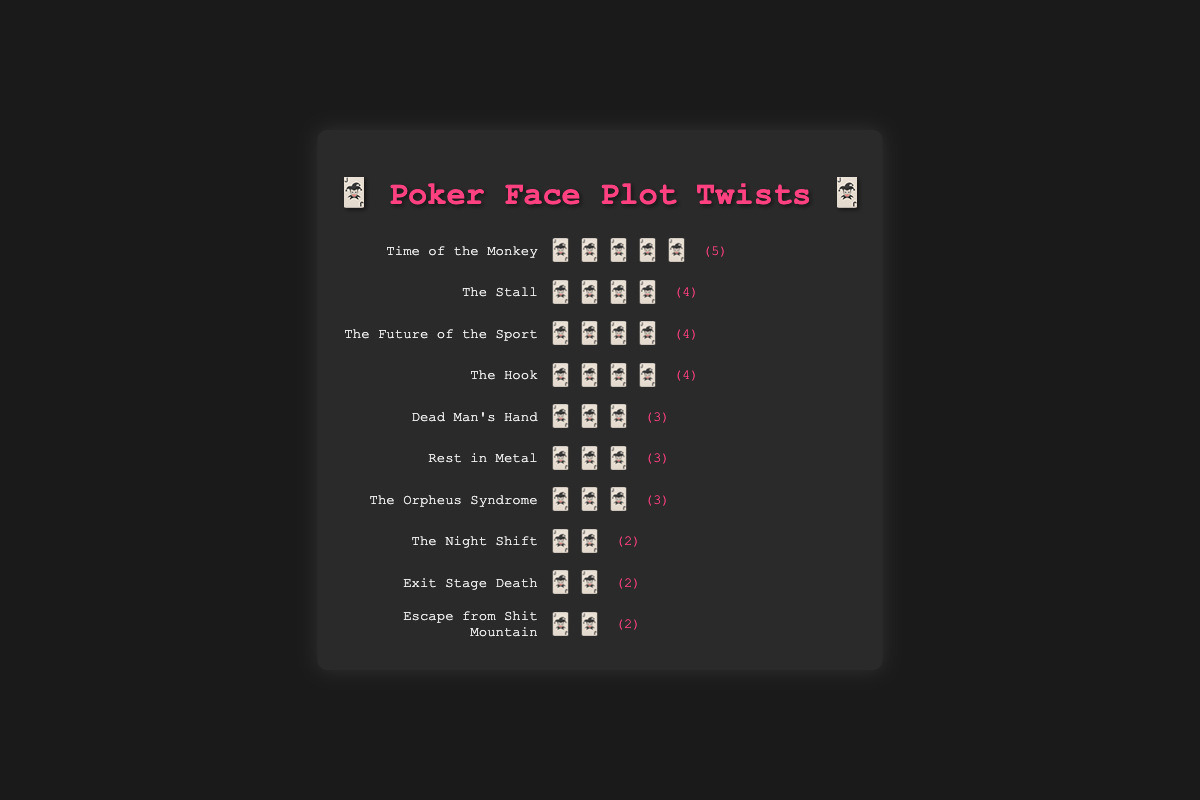what is the total number of plot twists in "The Stall"? Look at the episode named "The Stall" and count the number of plot twist emojis shown alongside it. "The Stall" has 4 plot twist emojis.
Answer: 4 Which episode has the most plot twists? Compare the number of plot twist emojis for each episode. The episode with the highest number of plot twists is "Time of the Monkey" with 5 plot twist emojis.
Answer: Time of the Monkey How many episodes have exactly 3 plot twists? Identify and count the episodes that have exactly 3 plot twist emojis. The episodes are "Dead Man's Hand", "Rest in Metal", and "The Orpheus Syndrome."
Answer: 3 What is the average number of plot twists per episode? Sum the total number of plot twists and divide by the number of episodes. The sum of plot twists is 32, and there are 10 episodes, so the average is 32/10.
Answer: 3.2 Which episode has fewer plot twists, "Exit Stage Death" or "The Hook"? Compare the number of plot twist emojis for "Exit Stage Death" and "The Hook." "Exit Stage Death" has 2 plot twist emojis, and "The Hook" has 4 plot twist emojis.
Answer: Exit Stage Death What is the difference in the number of plot twists between the episodes with the most and the least twists? Identify the episodes with the most (5, "Time of the Monkey") and the least (2, several episodes) plot twists and subtract the two values. The difference is 5 - 2.
Answer: 3 How many episodes have more than 3 plot twists? Count the number of episodes that have more than 3 plot twist emojis. The episodes are "Time of the Monkey," "The Stall," "The Future of the Sport," and "The Hook."
Answer: 4 Which episodes have the same number of plot twists as "The Orpheus Syndrome"? Compare the number of plot twist emojis in "The Orpheus Syndrome" with other episodes. The episodes with the same number of twists (3) are "Dead Man's Hand" and "Rest in Metal."
Answer: Dead Man's Hand, Rest in Metal Which episode appears first in the list with 4 plot twists? Identify the first episode by visually scanning the list from left to right. The first episode with 4 plot twists is "The Stall."
Answer: The Stall How many more plot twists does "Time of the Monkey" have compared to "Escape from Shit Mountain"? Subtract the number of plot twists in "Escape from Shit Mountain" (2) from "Time of the Monkey" (5). The difference is 5 - 2.
Answer: 3 